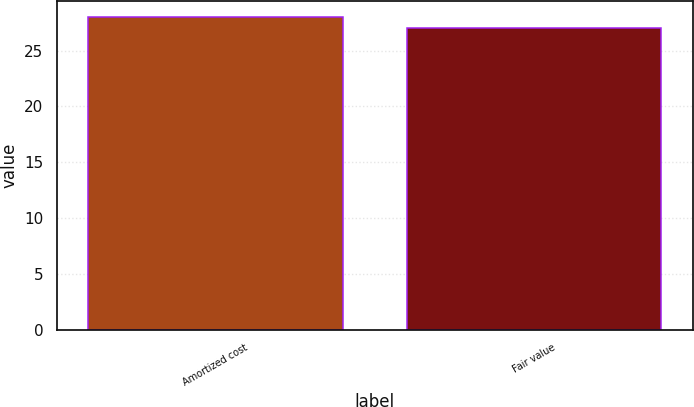<chart> <loc_0><loc_0><loc_500><loc_500><bar_chart><fcel>Amortized cost<fcel>Fair value<nl><fcel>28<fcel>27<nl></chart> 